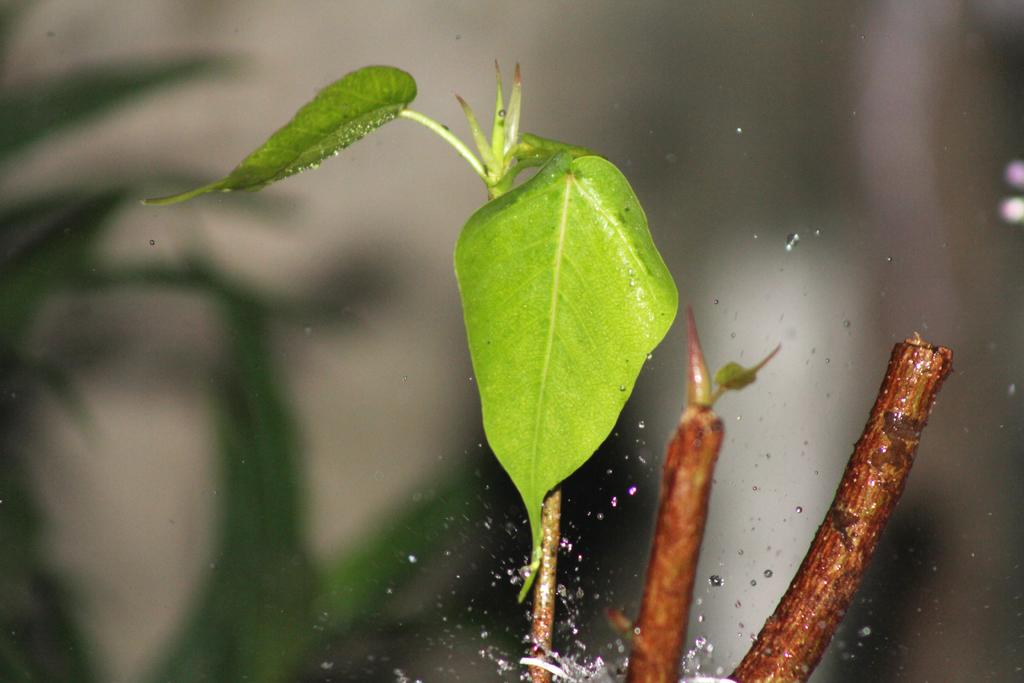What type of plant is visible in the image? The image contains leaves of a plant. What can be seen on the leaves of the plant? There are water droplets visible on the leaves of the plant. Can you describe the background of the image? The background of the image is blurred. What type of whip can be seen in the image? There is no whip present in the image. How many bulbs are visible in the image? There are no bulbs present in the image. 